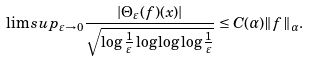Convert formula to latex. <formula><loc_0><loc_0><loc_500><loc_500>\lim s u p _ { \varepsilon \rightarrow 0 } \frac { | \Theta _ { \varepsilon } ( f ) ( x ) | } { \sqrt { \log \frac { 1 } { \varepsilon } \log \log \log \frac { 1 } { \varepsilon } } } \leq C ( \alpha ) \| f \| _ { \alpha } .</formula> 